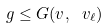<formula> <loc_0><loc_0><loc_500><loc_500>g \leq G ( v , \ v _ { \ell } )</formula> 